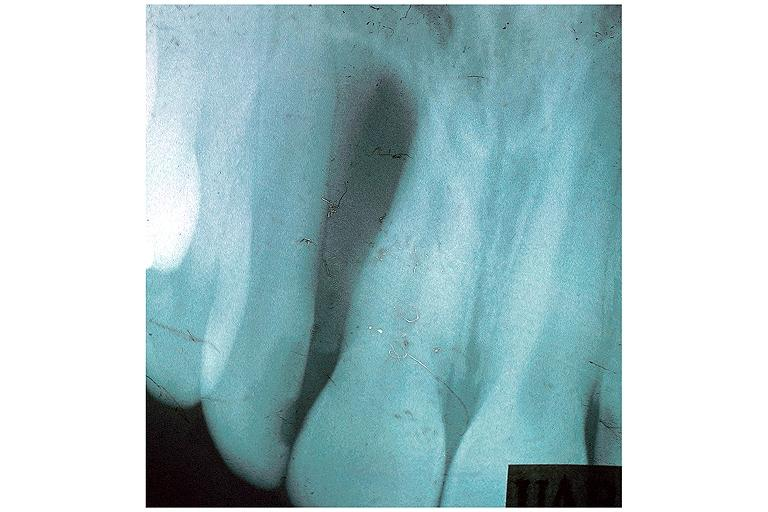does this image show globulomaxillary cyst?
Answer the question using a single word or phrase. Yes 